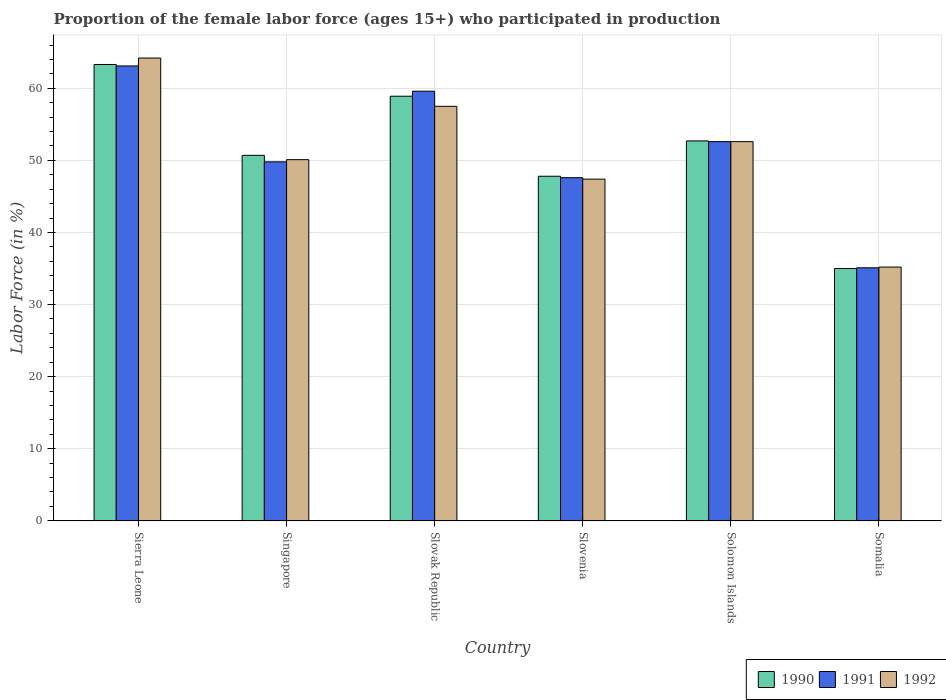How many groups of bars are there?
Your response must be concise. 6. How many bars are there on the 2nd tick from the left?
Provide a succinct answer. 3. What is the label of the 5th group of bars from the left?
Keep it short and to the point. Solomon Islands. In how many cases, is the number of bars for a given country not equal to the number of legend labels?
Give a very brief answer. 0. What is the proportion of the female labor force who participated in production in 1992 in Sierra Leone?
Offer a very short reply. 64.2. Across all countries, what is the maximum proportion of the female labor force who participated in production in 1990?
Give a very brief answer. 63.3. Across all countries, what is the minimum proportion of the female labor force who participated in production in 1992?
Provide a succinct answer. 35.2. In which country was the proportion of the female labor force who participated in production in 1992 maximum?
Ensure brevity in your answer.  Sierra Leone. In which country was the proportion of the female labor force who participated in production in 1992 minimum?
Ensure brevity in your answer.  Somalia. What is the total proportion of the female labor force who participated in production in 1992 in the graph?
Your answer should be very brief. 307. What is the difference between the proportion of the female labor force who participated in production in 1991 in Singapore and that in Somalia?
Make the answer very short. 14.7. What is the difference between the proportion of the female labor force who participated in production in 1992 in Solomon Islands and the proportion of the female labor force who participated in production in 1990 in Sierra Leone?
Ensure brevity in your answer.  -10.7. What is the average proportion of the female labor force who participated in production in 1990 per country?
Provide a short and direct response. 51.4. What is the difference between the proportion of the female labor force who participated in production of/in 1991 and proportion of the female labor force who participated in production of/in 1990 in Sierra Leone?
Provide a succinct answer. -0.2. In how many countries, is the proportion of the female labor force who participated in production in 1991 greater than 34 %?
Give a very brief answer. 6. What is the ratio of the proportion of the female labor force who participated in production in 1992 in Slovak Republic to that in Slovenia?
Provide a succinct answer. 1.21. Is the difference between the proportion of the female labor force who participated in production in 1991 in Sierra Leone and Slovenia greater than the difference between the proportion of the female labor force who participated in production in 1990 in Sierra Leone and Slovenia?
Keep it short and to the point. No. What is the difference between the highest and the second highest proportion of the female labor force who participated in production in 1990?
Make the answer very short. 6.2. What is the difference between the highest and the lowest proportion of the female labor force who participated in production in 1992?
Your response must be concise. 29. In how many countries, is the proportion of the female labor force who participated in production in 1992 greater than the average proportion of the female labor force who participated in production in 1992 taken over all countries?
Give a very brief answer. 3. Is the sum of the proportion of the female labor force who participated in production in 1990 in Slovenia and Somalia greater than the maximum proportion of the female labor force who participated in production in 1991 across all countries?
Ensure brevity in your answer.  Yes. How many bars are there?
Make the answer very short. 18. Are all the bars in the graph horizontal?
Offer a terse response. No. How many countries are there in the graph?
Make the answer very short. 6. Does the graph contain any zero values?
Make the answer very short. No. Does the graph contain grids?
Offer a very short reply. Yes. How many legend labels are there?
Provide a succinct answer. 3. How are the legend labels stacked?
Keep it short and to the point. Horizontal. What is the title of the graph?
Your answer should be compact. Proportion of the female labor force (ages 15+) who participated in production. Does "1977" appear as one of the legend labels in the graph?
Provide a short and direct response. No. What is the label or title of the X-axis?
Your answer should be compact. Country. What is the Labor Force (in %) in 1990 in Sierra Leone?
Your answer should be compact. 63.3. What is the Labor Force (in %) in 1991 in Sierra Leone?
Ensure brevity in your answer.  63.1. What is the Labor Force (in %) in 1992 in Sierra Leone?
Provide a succinct answer. 64.2. What is the Labor Force (in %) of 1990 in Singapore?
Your answer should be very brief. 50.7. What is the Labor Force (in %) in 1991 in Singapore?
Give a very brief answer. 49.8. What is the Labor Force (in %) of 1992 in Singapore?
Your answer should be very brief. 50.1. What is the Labor Force (in %) in 1990 in Slovak Republic?
Give a very brief answer. 58.9. What is the Labor Force (in %) of 1991 in Slovak Republic?
Keep it short and to the point. 59.6. What is the Labor Force (in %) in 1992 in Slovak Republic?
Keep it short and to the point. 57.5. What is the Labor Force (in %) in 1990 in Slovenia?
Provide a short and direct response. 47.8. What is the Labor Force (in %) of 1991 in Slovenia?
Your answer should be compact. 47.6. What is the Labor Force (in %) in 1992 in Slovenia?
Offer a very short reply. 47.4. What is the Labor Force (in %) in 1990 in Solomon Islands?
Provide a short and direct response. 52.7. What is the Labor Force (in %) in 1991 in Solomon Islands?
Your answer should be very brief. 52.6. What is the Labor Force (in %) in 1992 in Solomon Islands?
Give a very brief answer. 52.6. What is the Labor Force (in %) of 1991 in Somalia?
Offer a very short reply. 35.1. What is the Labor Force (in %) in 1992 in Somalia?
Your response must be concise. 35.2. Across all countries, what is the maximum Labor Force (in %) of 1990?
Ensure brevity in your answer.  63.3. Across all countries, what is the maximum Labor Force (in %) in 1991?
Offer a terse response. 63.1. Across all countries, what is the maximum Labor Force (in %) of 1992?
Ensure brevity in your answer.  64.2. Across all countries, what is the minimum Labor Force (in %) in 1990?
Ensure brevity in your answer.  35. Across all countries, what is the minimum Labor Force (in %) in 1991?
Provide a succinct answer. 35.1. Across all countries, what is the minimum Labor Force (in %) in 1992?
Give a very brief answer. 35.2. What is the total Labor Force (in %) in 1990 in the graph?
Provide a short and direct response. 308.4. What is the total Labor Force (in %) of 1991 in the graph?
Provide a short and direct response. 307.8. What is the total Labor Force (in %) in 1992 in the graph?
Make the answer very short. 307. What is the difference between the Labor Force (in %) of 1990 in Sierra Leone and that in Singapore?
Offer a terse response. 12.6. What is the difference between the Labor Force (in %) in 1991 in Sierra Leone and that in Slovak Republic?
Ensure brevity in your answer.  3.5. What is the difference between the Labor Force (in %) of 1990 in Sierra Leone and that in Slovenia?
Your answer should be compact. 15.5. What is the difference between the Labor Force (in %) of 1992 in Sierra Leone and that in Slovenia?
Your answer should be compact. 16.8. What is the difference between the Labor Force (in %) of 1990 in Sierra Leone and that in Somalia?
Make the answer very short. 28.3. What is the difference between the Labor Force (in %) in 1991 in Sierra Leone and that in Somalia?
Provide a short and direct response. 28. What is the difference between the Labor Force (in %) in 1992 in Sierra Leone and that in Somalia?
Make the answer very short. 29. What is the difference between the Labor Force (in %) in 1990 in Singapore and that in Slovak Republic?
Offer a very short reply. -8.2. What is the difference between the Labor Force (in %) of 1991 in Singapore and that in Slovak Republic?
Offer a very short reply. -9.8. What is the difference between the Labor Force (in %) of 1990 in Singapore and that in Slovenia?
Provide a succinct answer. 2.9. What is the difference between the Labor Force (in %) in 1991 in Singapore and that in Solomon Islands?
Your answer should be very brief. -2.8. What is the difference between the Labor Force (in %) of 1990 in Singapore and that in Somalia?
Your answer should be very brief. 15.7. What is the difference between the Labor Force (in %) of 1990 in Slovak Republic and that in Slovenia?
Ensure brevity in your answer.  11.1. What is the difference between the Labor Force (in %) of 1992 in Slovak Republic and that in Slovenia?
Ensure brevity in your answer.  10.1. What is the difference between the Labor Force (in %) of 1990 in Slovak Republic and that in Solomon Islands?
Offer a terse response. 6.2. What is the difference between the Labor Force (in %) of 1991 in Slovak Republic and that in Solomon Islands?
Offer a very short reply. 7. What is the difference between the Labor Force (in %) of 1992 in Slovak Republic and that in Solomon Islands?
Your answer should be compact. 4.9. What is the difference between the Labor Force (in %) of 1990 in Slovak Republic and that in Somalia?
Keep it short and to the point. 23.9. What is the difference between the Labor Force (in %) of 1992 in Slovak Republic and that in Somalia?
Ensure brevity in your answer.  22.3. What is the difference between the Labor Force (in %) in 1990 in Slovenia and that in Solomon Islands?
Provide a short and direct response. -4.9. What is the difference between the Labor Force (in %) of 1991 in Slovenia and that in Solomon Islands?
Keep it short and to the point. -5. What is the difference between the Labor Force (in %) in 1992 in Slovenia and that in Solomon Islands?
Ensure brevity in your answer.  -5.2. What is the difference between the Labor Force (in %) in 1990 in Slovenia and that in Somalia?
Your response must be concise. 12.8. What is the difference between the Labor Force (in %) of 1991 in Slovenia and that in Somalia?
Your answer should be very brief. 12.5. What is the difference between the Labor Force (in %) in 1990 in Sierra Leone and the Labor Force (in %) in 1991 in Singapore?
Your answer should be very brief. 13.5. What is the difference between the Labor Force (in %) of 1991 in Sierra Leone and the Labor Force (in %) of 1992 in Slovak Republic?
Give a very brief answer. 5.6. What is the difference between the Labor Force (in %) in 1991 in Sierra Leone and the Labor Force (in %) in 1992 in Slovenia?
Give a very brief answer. 15.7. What is the difference between the Labor Force (in %) of 1990 in Sierra Leone and the Labor Force (in %) of 1991 in Somalia?
Give a very brief answer. 28.2. What is the difference between the Labor Force (in %) of 1990 in Sierra Leone and the Labor Force (in %) of 1992 in Somalia?
Make the answer very short. 28.1. What is the difference between the Labor Force (in %) of 1991 in Sierra Leone and the Labor Force (in %) of 1992 in Somalia?
Give a very brief answer. 27.9. What is the difference between the Labor Force (in %) of 1990 in Singapore and the Labor Force (in %) of 1991 in Slovak Republic?
Make the answer very short. -8.9. What is the difference between the Labor Force (in %) of 1990 in Singapore and the Labor Force (in %) of 1992 in Slovak Republic?
Keep it short and to the point. -6.8. What is the difference between the Labor Force (in %) in 1991 in Singapore and the Labor Force (in %) in 1992 in Slovak Republic?
Provide a succinct answer. -7.7. What is the difference between the Labor Force (in %) of 1990 in Singapore and the Labor Force (in %) of 1992 in Slovenia?
Make the answer very short. 3.3. What is the difference between the Labor Force (in %) in 1991 in Singapore and the Labor Force (in %) in 1992 in Slovenia?
Your answer should be compact. 2.4. What is the difference between the Labor Force (in %) in 1990 in Singapore and the Labor Force (in %) in 1992 in Solomon Islands?
Provide a short and direct response. -1.9. What is the difference between the Labor Force (in %) in 1991 in Singapore and the Labor Force (in %) in 1992 in Solomon Islands?
Your answer should be very brief. -2.8. What is the difference between the Labor Force (in %) of 1990 in Singapore and the Labor Force (in %) of 1991 in Somalia?
Keep it short and to the point. 15.6. What is the difference between the Labor Force (in %) of 1990 in Slovak Republic and the Labor Force (in %) of 1992 in Slovenia?
Your answer should be compact. 11.5. What is the difference between the Labor Force (in %) in 1991 in Slovak Republic and the Labor Force (in %) in 1992 in Slovenia?
Keep it short and to the point. 12.2. What is the difference between the Labor Force (in %) of 1990 in Slovak Republic and the Labor Force (in %) of 1991 in Solomon Islands?
Make the answer very short. 6.3. What is the difference between the Labor Force (in %) of 1990 in Slovak Republic and the Labor Force (in %) of 1992 in Solomon Islands?
Give a very brief answer. 6.3. What is the difference between the Labor Force (in %) in 1990 in Slovak Republic and the Labor Force (in %) in 1991 in Somalia?
Keep it short and to the point. 23.8. What is the difference between the Labor Force (in %) in 1990 in Slovak Republic and the Labor Force (in %) in 1992 in Somalia?
Provide a short and direct response. 23.7. What is the difference between the Labor Force (in %) in 1991 in Slovak Republic and the Labor Force (in %) in 1992 in Somalia?
Offer a terse response. 24.4. What is the difference between the Labor Force (in %) in 1990 in Slovenia and the Labor Force (in %) in 1991 in Solomon Islands?
Offer a very short reply. -4.8. What is the difference between the Labor Force (in %) in 1990 in Slovenia and the Labor Force (in %) in 1991 in Somalia?
Your answer should be very brief. 12.7. What is the difference between the Labor Force (in %) of 1990 in Slovenia and the Labor Force (in %) of 1992 in Somalia?
Your response must be concise. 12.6. What is the average Labor Force (in %) of 1990 per country?
Provide a succinct answer. 51.4. What is the average Labor Force (in %) in 1991 per country?
Provide a succinct answer. 51.3. What is the average Labor Force (in %) in 1992 per country?
Make the answer very short. 51.17. What is the difference between the Labor Force (in %) of 1991 and Labor Force (in %) of 1992 in Sierra Leone?
Your answer should be very brief. -1.1. What is the difference between the Labor Force (in %) of 1990 and Labor Force (in %) of 1991 in Singapore?
Give a very brief answer. 0.9. What is the difference between the Labor Force (in %) of 1990 and Labor Force (in %) of 1991 in Slovak Republic?
Offer a terse response. -0.7. What is the difference between the Labor Force (in %) of 1990 and Labor Force (in %) of 1992 in Slovak Republic?
Provide a short and direct response. 1.4. What is the difference between the Labor Force (in %) of 1991 and Labor Force (in %) of 1992 in Slovak Republic?
Provide a short and direct response. 2.1. What is the difference between the Labor Force (in %) of 1990 and Labor Force (in %) of 1991 in Solomon Islands?
Ensure brevity in your answer.  0.1. What is the difference between the Labor Force (in %) of 1990 and Labor Force (in %) of 1992 in Solomon Islands?
Offer a very short reply. 0.1. What is the difference between the Labor Force (in %) in 1991 and Labor Force (in %) in 1992 in Solomon Islands?
Your answer should be very brief. 0. What is the ratio of the Labor Force (in %) of 1990 in Sierra Leone to that in Singapore?
Your response must be concise. 1.25. What is the ratio of the Labor Force (in %) of 1991 in Sierra Leone to that in Singapore?
Provide a short and direct response. 1.27. What is the ratio of the Labor Force (in %) of 1992 in Sierra Leone to that in Singapore?
Your answer should be compact. 1.28. What is the ratio of the Labor Force (in %) of 1990 in Sierra Leone to that in Slovak Republic?
Keep it short and to the point. 1.07. What is the ratio of the Labor Force (in %) of 1991 in Sierra Leone to that in Slovak Republic?
Your answer should be very brief. 1.06. What is the ratio of the Labor Force (in %) of 1992 in Sierra Leone to that in Slovak Republic?
Your response must be concise. 1.12. What is the ratio of the Labor Force (in %) in 1990 in Sierra Leone to that in Slovenia?
Offer a terse response. 1.32. What is the ratio of the Labor Force (in %) in 1991 in Sierra Leone to that in Slovenia?
Provide a succinct answer. 1.33. What is the ratio of the Labor Force (in %) in 1992 in Sierra Leone to that in Slovenia?
Your response must be concise. 1.35. What is the ratio of the Labor Force (in %) of 1990 in Sierra Leone to that in Solomon Islands?
Your answer should be compact. 1.2. What is the ratio of the Labor Force (in %) of 1991 in Sierra Leone to that in Solomon Islands?
Give a very brief answer. 1.2. What is the ratio of the Labor Force (in %) in 1992 in Sierra Leone to that in Solomon Islands?
Give a very brief answer. 1.22. What is the ratio of the Labor Force (in %) in 1990 in Sierra Leone to that in Somalia?
Ensure brevity in your answer.  1.81. What is the ratio of the Labor Force (in %) in 1991 in Sierra Leone to that in Somalia?
Provide a succinct answer. 1.8. What is the ratio of the Labor Force (in %) in 1992 in Sierra Leone to that in Somalia?
Provide a succinct answer. 1.82. What is the ratio of the Labor Force (in %) of 1990 in Singapore to that in Slovak Republic?
Keep it short and to the point. 0.86. What is the ratio of the Labor Force (in %) in 1991 in Singapore to that in Slovak Republic?
Offer a terse response. 0.84. What is the ratio of the Labor Force (in %) of 1992 in Singapore to that in Slovak Republic?
Keep it short and to the point. 0.87. What is the ratio of the Labor Force (in %) in 1990 in Singapore to that in Slovenia?
Offer a terse response. 1.06. What is the ratio of the Labor Force (in %) in 1991 in Singapore to that in Slovenia?
Your answer should be very brief. 1.05. What is the ratio of the Labor Force (in %) of 1992 in Singapore to that in Slovenia?
Make the answer very short. 1.06. What is the ratio of the Labor Force (in %) of 1991 in Singapore to that in Solomon Islands?
Make the answer very short. 0.95. What is the ratio of the Labor Force (in %) in 1992 in Singapore to that in Solomon Islands?
Keep it short and to the point. 0.95. What is the ratio of the Labor Force (in %) in 1990 in Singapore to that in Somalia?
Give a very brief answer. 1.45. What is the ratio of the Labor Force (in %) in 1991 in Singapore to that in Somalia?
Provide a succinct answer. 1.42. What is the ratio of the Labor Force (in %) of 1992 in Singapore to that in Somalia?
Keep it short and to the point. 1.42. What is the ratio of the Labor Force (in %) of 1990 in Slovak Republic to that in Slovenia?
Make the answer very short. 1.23. What is the ratio of the Labor Force (in %) in 1991 in Slovak Republic to that in Slovenia?
Provide a succinct answer. 1.25. What is the ratio of the Labor Force (in %) of 1992 in Slovak Republic to that in Slovenia?
Give a very brief answer. 1.21. What is the ratio of the Labor Force (in %) of 1990 in Slovak Republic to that in Solomon Islands?
Your answer should be very brief. 1.12. What is the ratio of the Labor Force (in %) in 1991 in Slovak Republic to that in Solomon Islands?
Your response must be concise. 1.13. What is the ratio of the Labor Force (in %) in 1992 in Slovak Republic to that in Solomon Islands?
Your answer should be very brief. 1.09. What is the ratio of the Labor Force (in %) in 1990 in Slovak Republic to that in Somalia?
Keep it short and to the point. 1.68. What is the ratio of the Labor Force (in %) of 1991 in Slovak Republic to that in Somalia?
Offer a very short reply. 1.7. What is the ratio of the Labor Force (in %) in 1992 in Slovak Republic to that in Somalia?
Keep it short and to the point. 1.63. What is the ratio of the Labor Force (in %) in 1990 in Slovenia to that in Solomon Islands?
Make the answer very short. 0.91. What is the ratio of the Labor Force (in %) in 1991 in Slovenia to that in Solomon Islands?
Provide a short and direct response. 0.9. What is the ratio of the Labor Force (in %) of 1992 in Slovenia to that in Solomon Islands?
Your answer should be compact. 0.9. What is the ratio of the Labor Force (in %) of 1990 in Slovenia to that in Somalia?
Provide a succinct answer. 1.37. What is the ratio of the Labor Force (in %) of 1991 in Slovenia to that in Somalia?
Make the answer very short. 1.36. What is the ratio of the Labor Force (in %) of 1992 in Slovenia to that in Somalia?
Your answer should be very brief. 1.35. What is the ratio of the Labor Force (in %) in 1990 in Solomon Islands to that in Somalia?
Provide a short and direct response. 1.51. What is the ratio of the Labor Force (in %) in 1991 in Solomon Islands to that in Somalia?
Offer a terse response. 1.5. What is the ratio of the Labor Force (in %) of 1992 in Solomon Islands to that in Somalia?
Ensure brevity in your answer.  1.49. What is the difference between the highest and the second highest Labor Force (in %) of 1991?
Keep it short and to the point. 3.5. What is the difference between the highest and the second highest Labor Force (in %) of 1992?
Provide a short and direct response. 6.7. What is the difference between the highest and the lowest Labor Force (in %) of 1990?
Your answer should be compact. 28.3. What is the difference between the highest and the lowest Labor Force (in %) in 1991?
Your response must be concise. 28. 